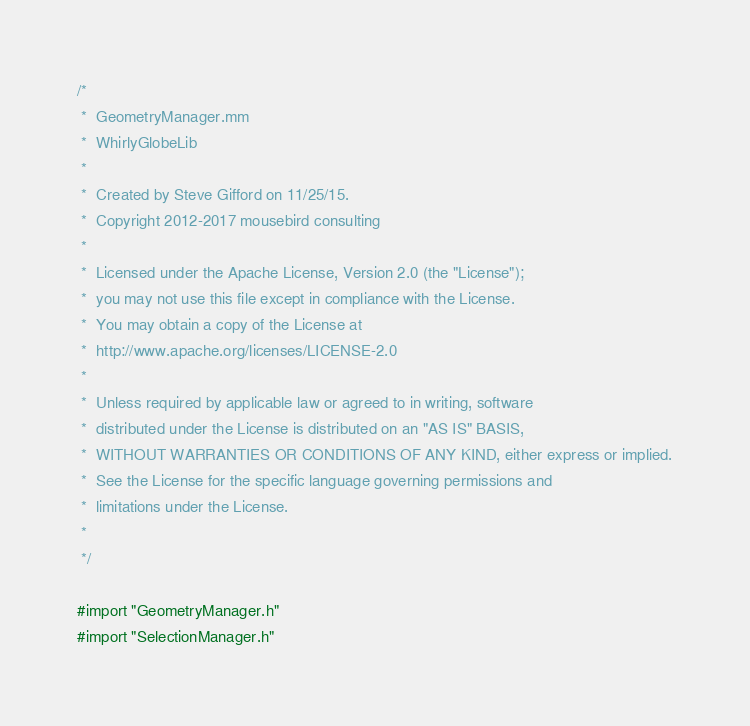<code> <loc_0><loc_0><loc_500><loc_500><_ObjectiveC_>/*
 *  GeometryManager.mm
 *  WhirlyGlobeLib
 *
 *  Created by Steve Gifford on 11/25/15.
 *  Copyright 2012-2017 mousebird consulting
 *
 *  Licensed under the Apache License, Version 2.0 (the "License");
 *  you may not use this file except in compliance with the License.
 *  You may obtain a copy of the License at
 *  http://www.apache.org/licenses/LICENSE-2.0
 *
 *  Unless required by applicable law or agreed to in writing, software
 *  distributed under the License is distributed on an "AS IS" BASIS,
 *  WITHOUT WARRANTIES OR CONDITIONS OF ANY KIND, either express or implied.
 *  See the License for the specific language governing permissions and
 *  limitations under the License.
 *
 */

#import "GeometryManager.h"
#import "SelectionManager.h"</code> 